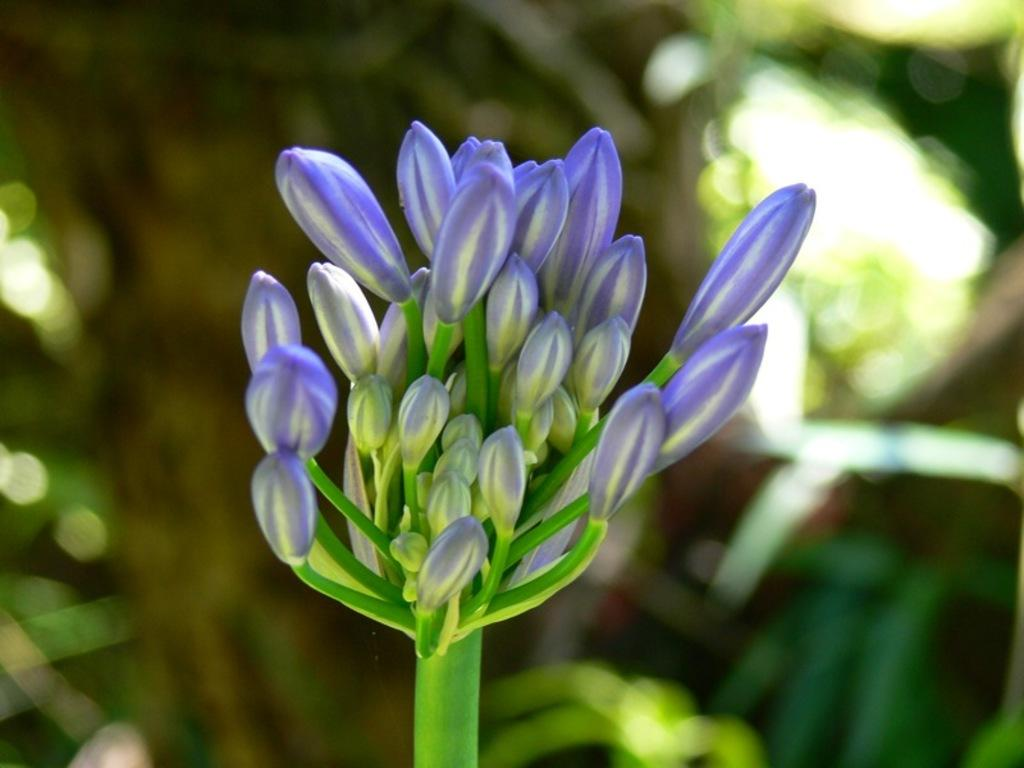What is the main subject of the image? The main subject of the image is buds. Can you describe the location of the buds in the image? The buds are in the center of the image. What type of friction can be observed between the buds in the image? There is no friction present between the buds in the image, as they are not interacting with each other or any other objects. 